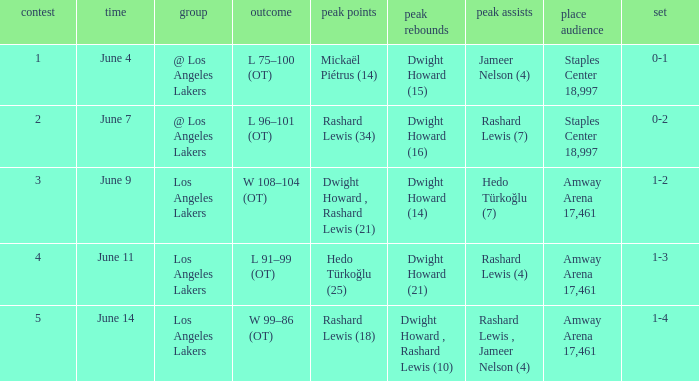What is Series, when Date is "June 7"? 0-2. 